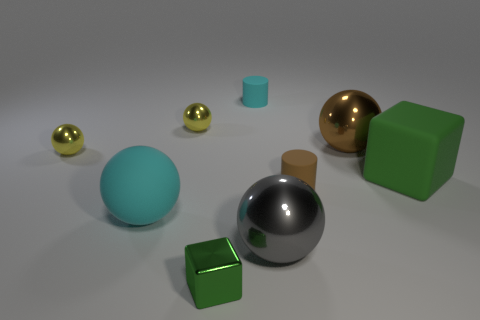Is the cube that is right of the cyan rubber cylinder made of the same material as the big gray thing?
Provide a succinct answer. No. Is the large gray object that is in front of the small cyan matte cylinder made of the same material as the tiny yellow ball behind the big brown metal object?
Your answer should be compact. Yes. Is the number of metal cubes that are to the right of the gray sphere greater than the number of small brown rubber cylinders?
Keep it short and to the point. No. There is a cylinder that is behind the large metallic thing behind the big cyan sphere; what is its color?
Give a very brief answer. Cyan. The green rubber thing that is the same size as the rubber sphere is what shape?
Make the answer very short. Cube. What is the shape of the tiny matte object that is the same color as the matte sphere?
Keep it short and to the point. Cylinder. Are there an equal number of large metallic spheres that are on the right side of the brown cylinder and large yellow metallic cylinders?
Your response must be concise. No. What material is the brown thing that is behind the rubber cylinder to the right of the rubber cylinder that is behind the brown matte object made of?
Your answer should be compact. Metal. There is a small cyan object that is made of the same material as the cyan sphere; what shape is it?
Your response must be concise. Cylinder. Is there anything else that has the same color as the metallic block?
Provide a succinct answer. Yes. 